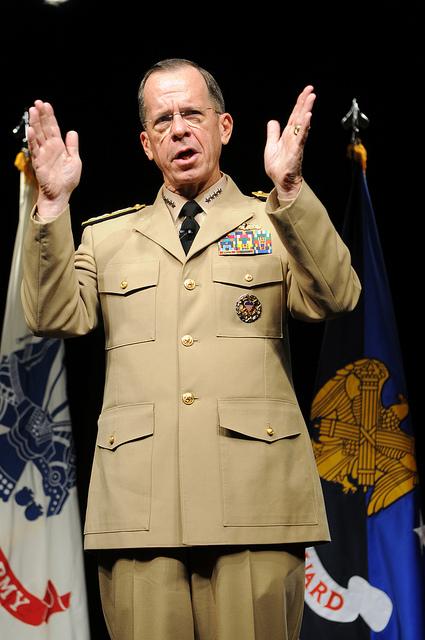Is this person clapping his hands?
Give a very brief answer. No. What color is the person's tie?
Concise answer only. Black. Is the person in the image a female?
Keep it brief. No. 